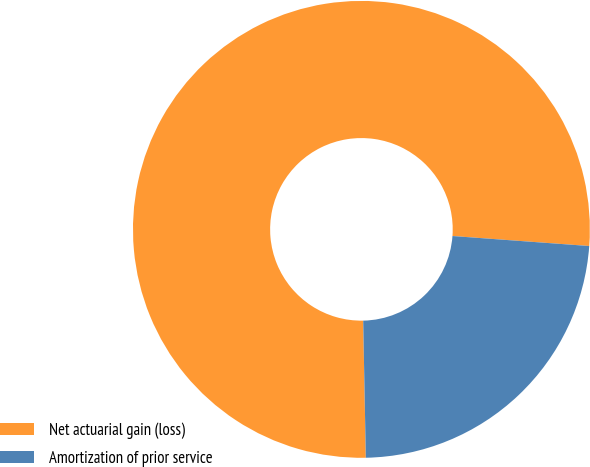<chart> <loc_0><loc_0><loc_500><loc_500><pie_chart><fcel>Net actuarial gain (loss)<fcel>Amortization of prior service<nl><fcel>76.47%<fcel>23.53%<nl></chart> 